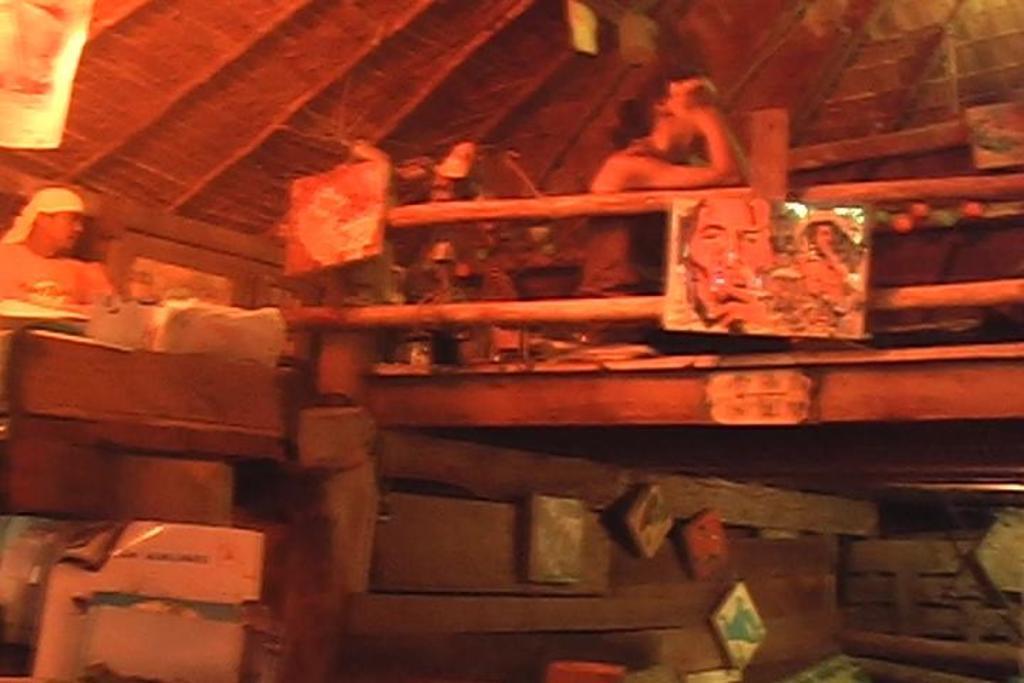Please provide a concise description of this image. In this picture we can see people, here we can see a photo frame, poster, wooden objects and some objects and in the background we can see a roof. 